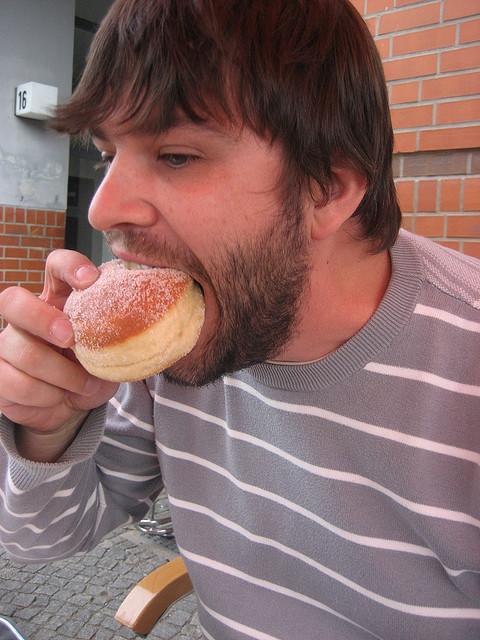Does the man have any facial hair?
Give a very brief answer. Yes. Does this pastry normally have a filling?
Concise answer only. Yes. What is the man eating?
Answer briefly. Donut. 